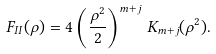Convert formula to latex. <formula><loc_0><loc_0><loc_500><loc_500>F _ { I I } ( \rho ) = 4 \left ( \frac { \rho ^ { 2 } } { 2 } \right ) ^ { m + j } \, K _ { m + j } ( \rho ^ { 2 } ) .</formula> 